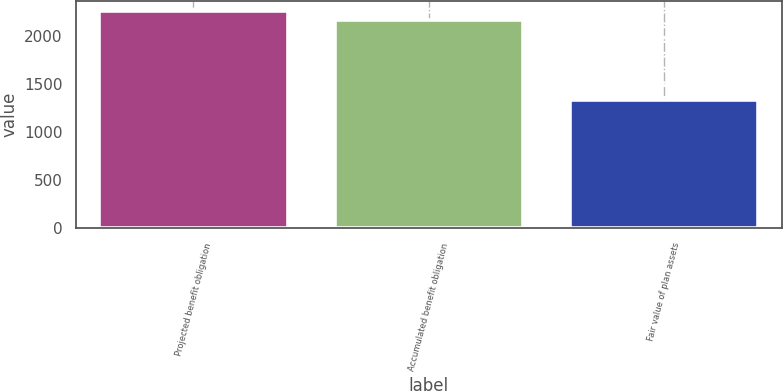Convert chart to OTSL. <chart><loc_0><loc_0><loc_500><loc_500><bar_chart><fcel>Projected benefit obligation<fcel>Accumulated benefit obligation<fcel>Fair value of plan assets<nl><fcel>2253.2<fcel>2162<fcel>1338<nl></chart> 